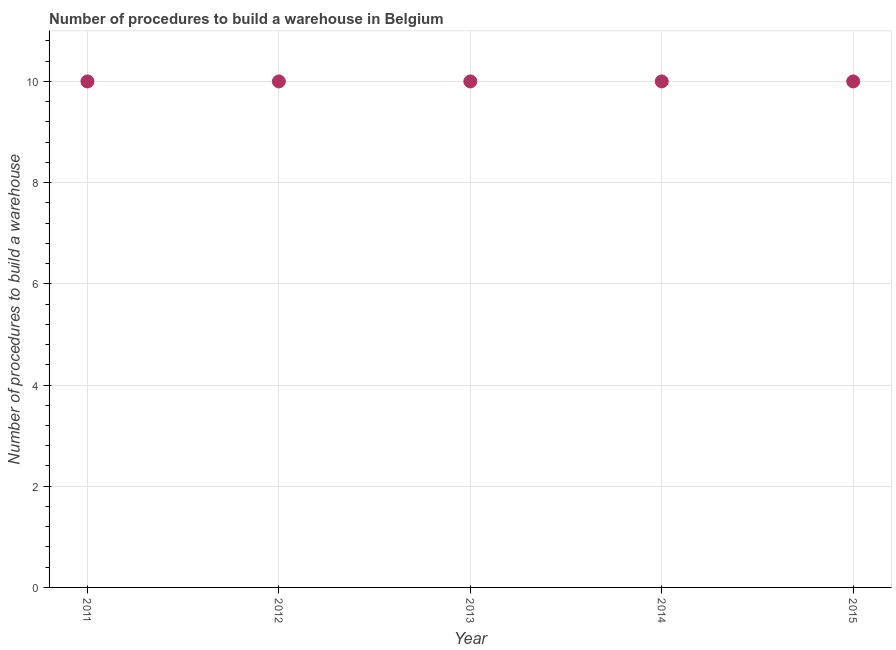What is the number of procedures to build a warehouse in 2011?
Your response must be concise. 10. Across all years, what is the maximum number of procedures to build a warehouse?
Give a very brief answer. 10. Across all years, what is the minimum number of procedures to build a warehouse?
Your answer should be compact. 10. What is the sum of the number of procedures to build a warehouse?
Give a very brief answer. 50. What is the difference between the number of procedures to build a warehouse in 2011 and 2015?
Offer a terse response. 0. In how many years, is the number of procedures to build a warehouse greater than 3.2 ?
Give a very brief answer. 5. Do a majority of the years between 2014 and 2013 (inclusive) have number of procedures to build a warehouse greater than 1.6 ?
Provide a short and direct response. No. What is the ratio of the number of procedures to build a warehouse in 2012 to that in 2015?
Your answer should be compact. 1. Is the difference between the number of procedures to build a warehouse in 2013 and 2014 greater than the difference between any two years?
Your response must be concise. Yes. Is the sum of the number of procedures to build a warehouse in 2011 and 2015 greater than the maximum number of procedures to build a warehouse across all years?
Give a very brief answer. Yes. Does the graph contain any zero values?
Provide a succinct answer. No. Does the graph contain grids?
Your answer should be very brief. Yes. What is the title of the graph?
Ensure brevity in your answer.  Number of procedures to build a warehouse in Belgium. What is the label or title of the Y-axis?
Offer a very short reply. Number of procedures to build a warehouse. What is the Number of procedures to build a warehouse in 2012?
Offer a very short reply. 10. What is the Number of procedures to build a warehouse in 2015?
Give a very brief answer. 10. What is the difference between the Number of procedures to build a warehouse in 2011 and 2014?
Your answer should be very brief. 0. What is the difference between the Number of procedures to build a warehouse in 2012 and 2014?
Your answer should be compact. 0. What is the difference between the Number of procedures to build a warehouse in 2012 and 2015?
Your answer should be compact. 0. What is the difference between the Number of procedures to build a warehouse in 2013 and 2014?
Your answer should be compact. 0. What is the difference between the Number of procedures to build a warehouse in 2014 and 2015?
Provide a succinct answer. 0. What is the ratio of the Number of procedures to build a warehouse in 2011 to that in 2013?
Provide a succinct answer. 1. What is the ratio of the Number of procedures to build a warehouse in 2011 to that in 2014?
Make the answer very short. 1. What is the ratio of the Number of procedures to build a warehouse in 2012 to that in 2014?
Offer a very short reply. 1. What is the ratio of the Number of procedures to build a warehouse in 2012 to that in 2015?
Provide a short and direct response. 1. What is the ratio of the Number of procedures to build a warehouse in 2013 to that in 2014?
Provide a succinct answer. 1. What is the ratio of the Number of procedures to build a warehouse in 2013 to that in 2015?
Give a very brief answer. 1. 